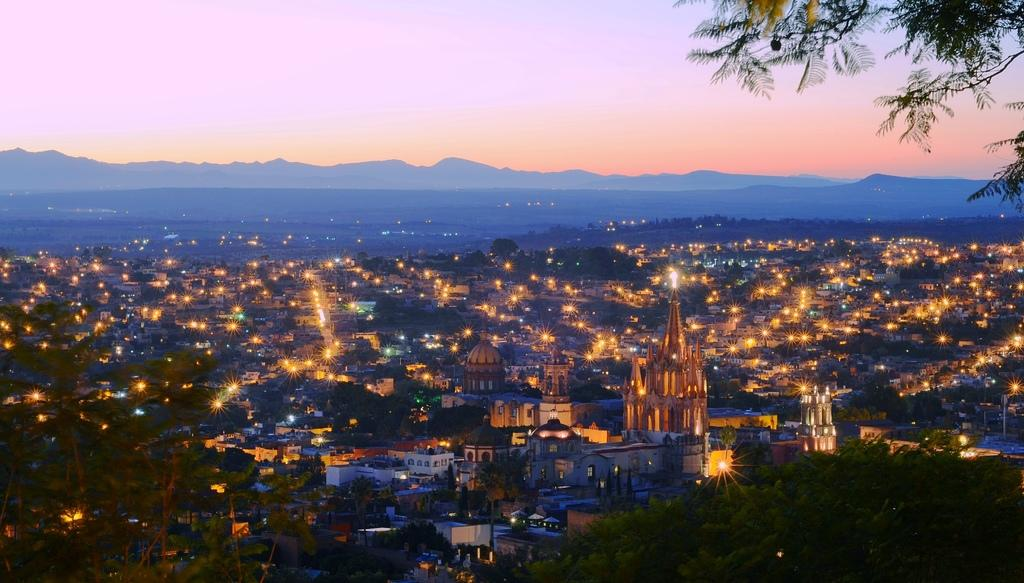What type of natural feature can be seen in the image? There are hills in the image. What type of man-made structures are present in the image? There are buildings in the image. What type of illumination is visible in the image? There are lights in the image. What type of vegetation is present in the image? There are trees in the image. What is visible at the top of the image? The sky is visible at the top of the image. What type of soap is being used to clean the buildings in the image? There is no soap present in the image, and the buildings are not being cleaned. What type of teaching is taking place in the image? There is no teaching activity present in the image. 